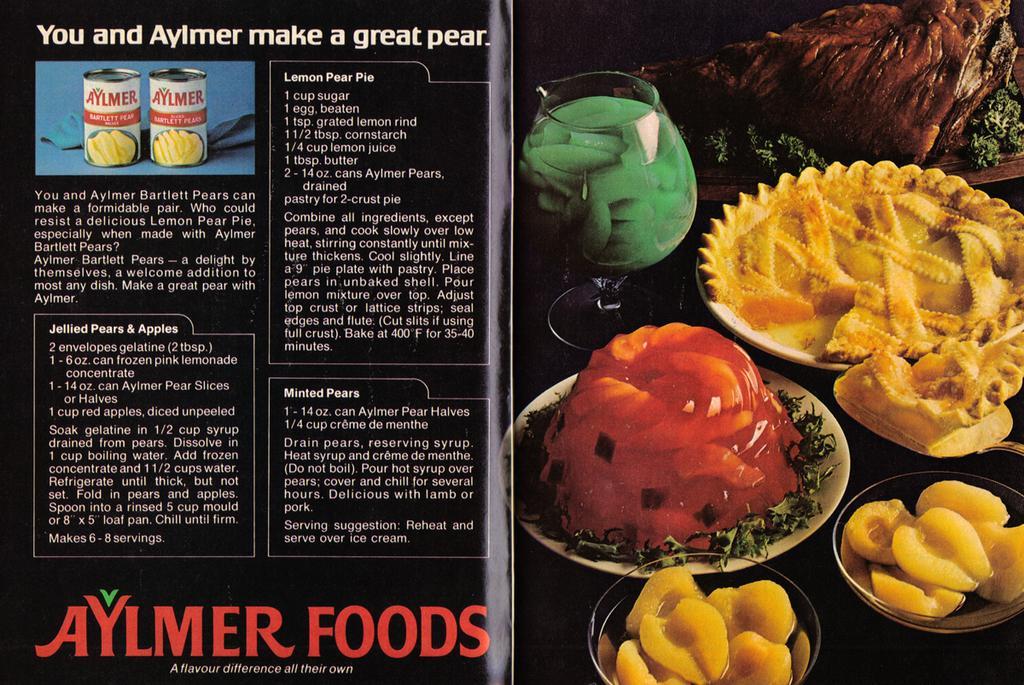In one or two sentences, can you explain what this image depicts? In this image, we can see a flyer contains food items and some text. 